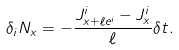Convert formula to latex. <formula><loc_0><loc_0><loc_500><loc_500>\delta _ { i } N _ { x } = - \frac { J ^ { i } _ { x + \ell e ^ { i } } - J ^ { i } _ { x } } { \ell } \delta t .</formula> 